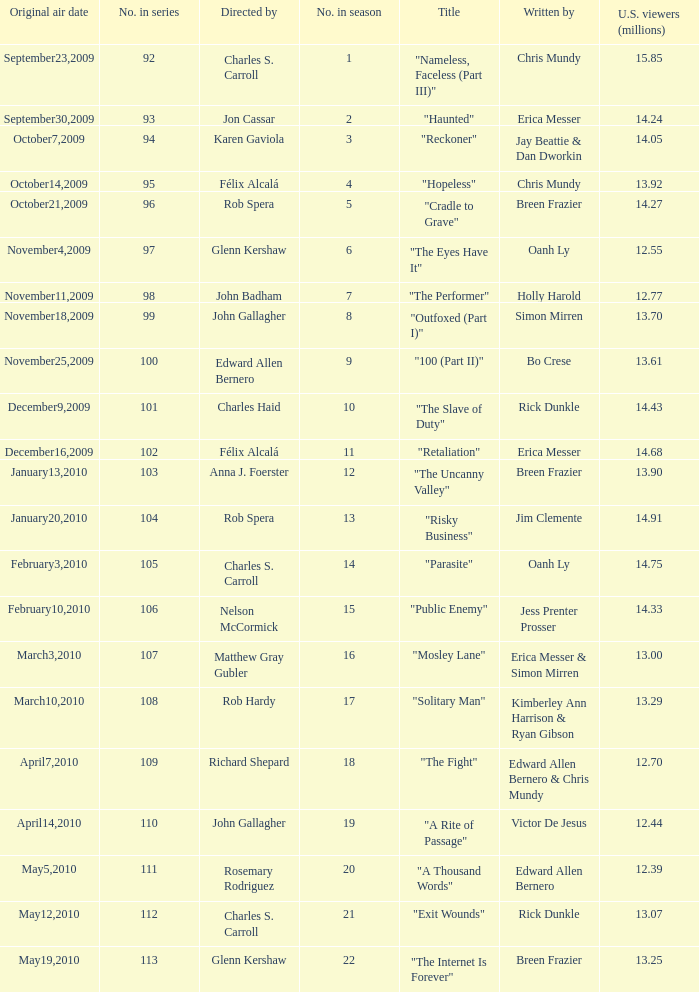What number(s) in the series was written by bo crese? 100.0. 